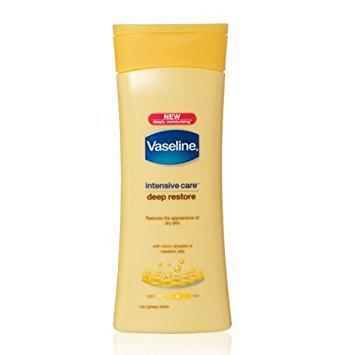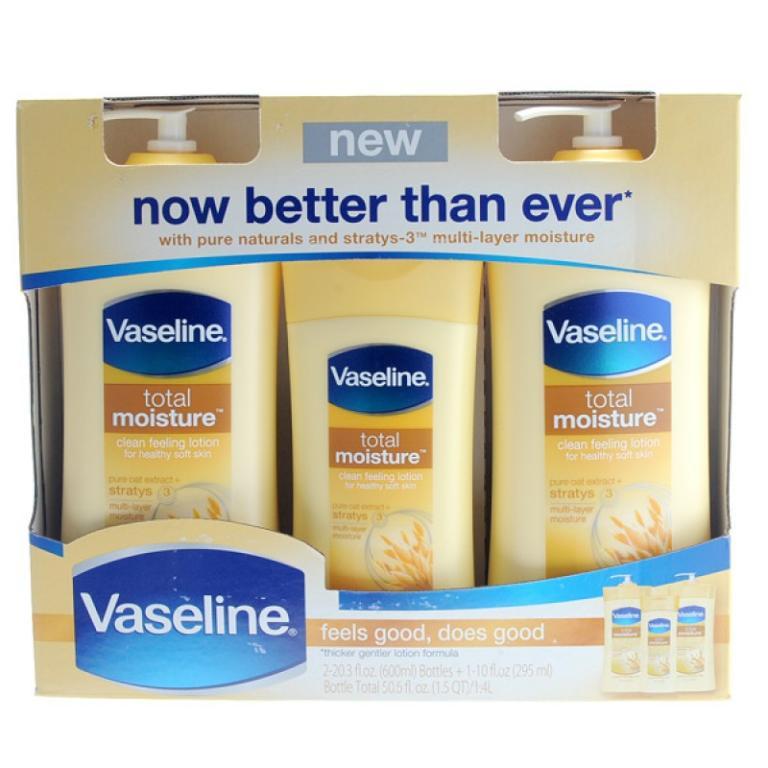The first image is the image on the left, the second image is the image on the right. Considering the images on both sides, is "The containers in the left image are all brown." valid? Answer yes or no. No. The first image is the image on the left, the second image is the image on the right. Examine the images to the left and right. Is the description "Some bottles of Vaseline are still in the package." accurate? Answer yes or no. Yes. 